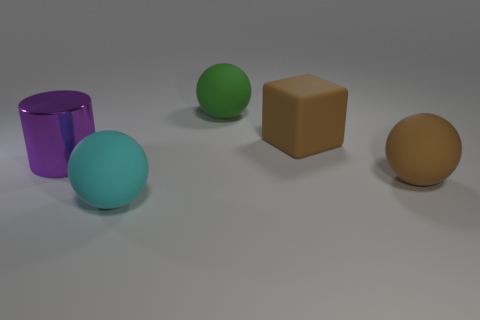Add 1 large green matte balls. How many objects exist? 6 Subtract all cylinders. How many objects are left? 4 Add 2 big green rubber spheres. How many big green rubber spheres exist? 3 Subtract 0 cyan cubes. How many objects are left? 5 Subtract all big brown things. Subtract all brown cubes. How many objects are left? 2 Add 3 purple shiny objects. How many purple shiny objects are left? 4 